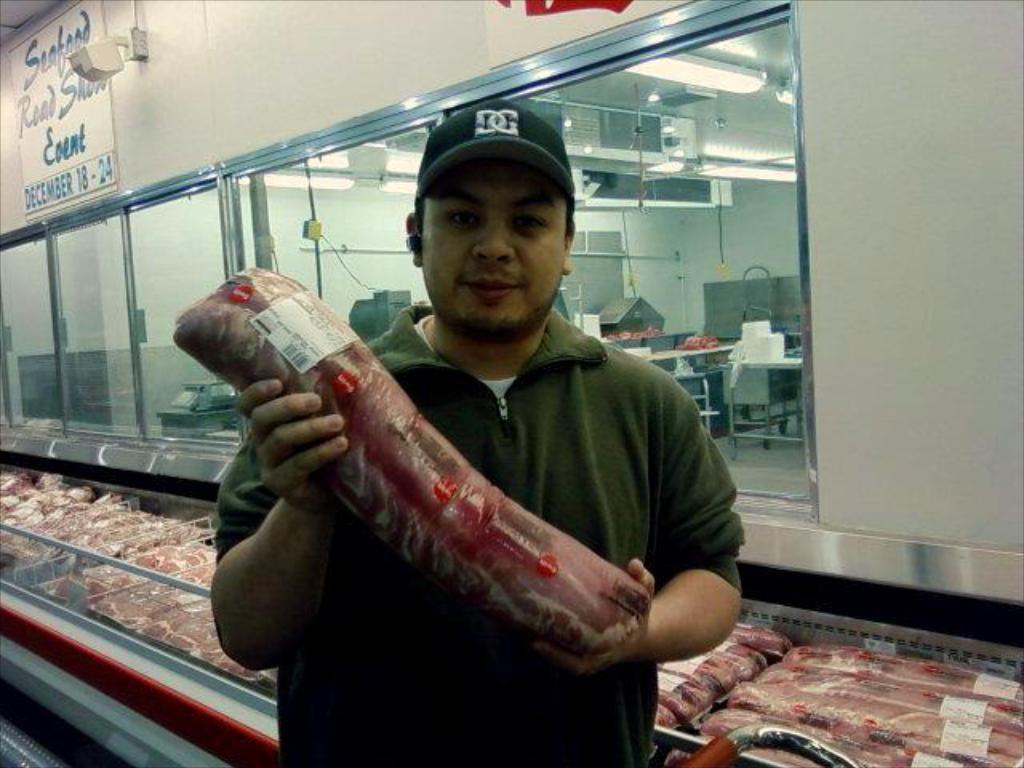Please provide a concise description of this image. In this picture we can see a man wore a cap, holding a packet with his hands and at the back of him we can see packets, glass windows, posters, lights and some objects. 